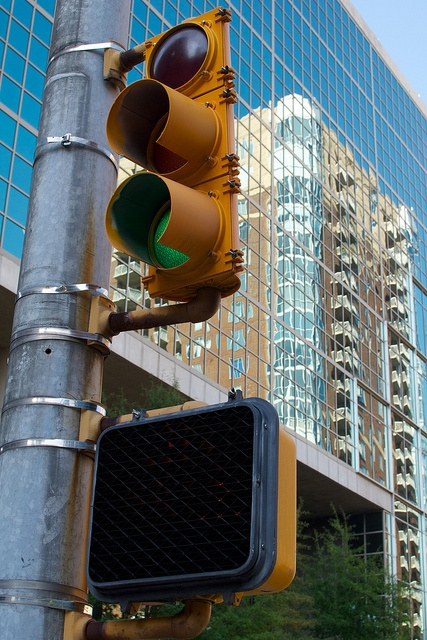Describe the objects in this image and their specific colors. I can see traffic light in teal, black, blue, navy, and gray tones and traffic light in teal, black, maroon, and olive tones in this image. 